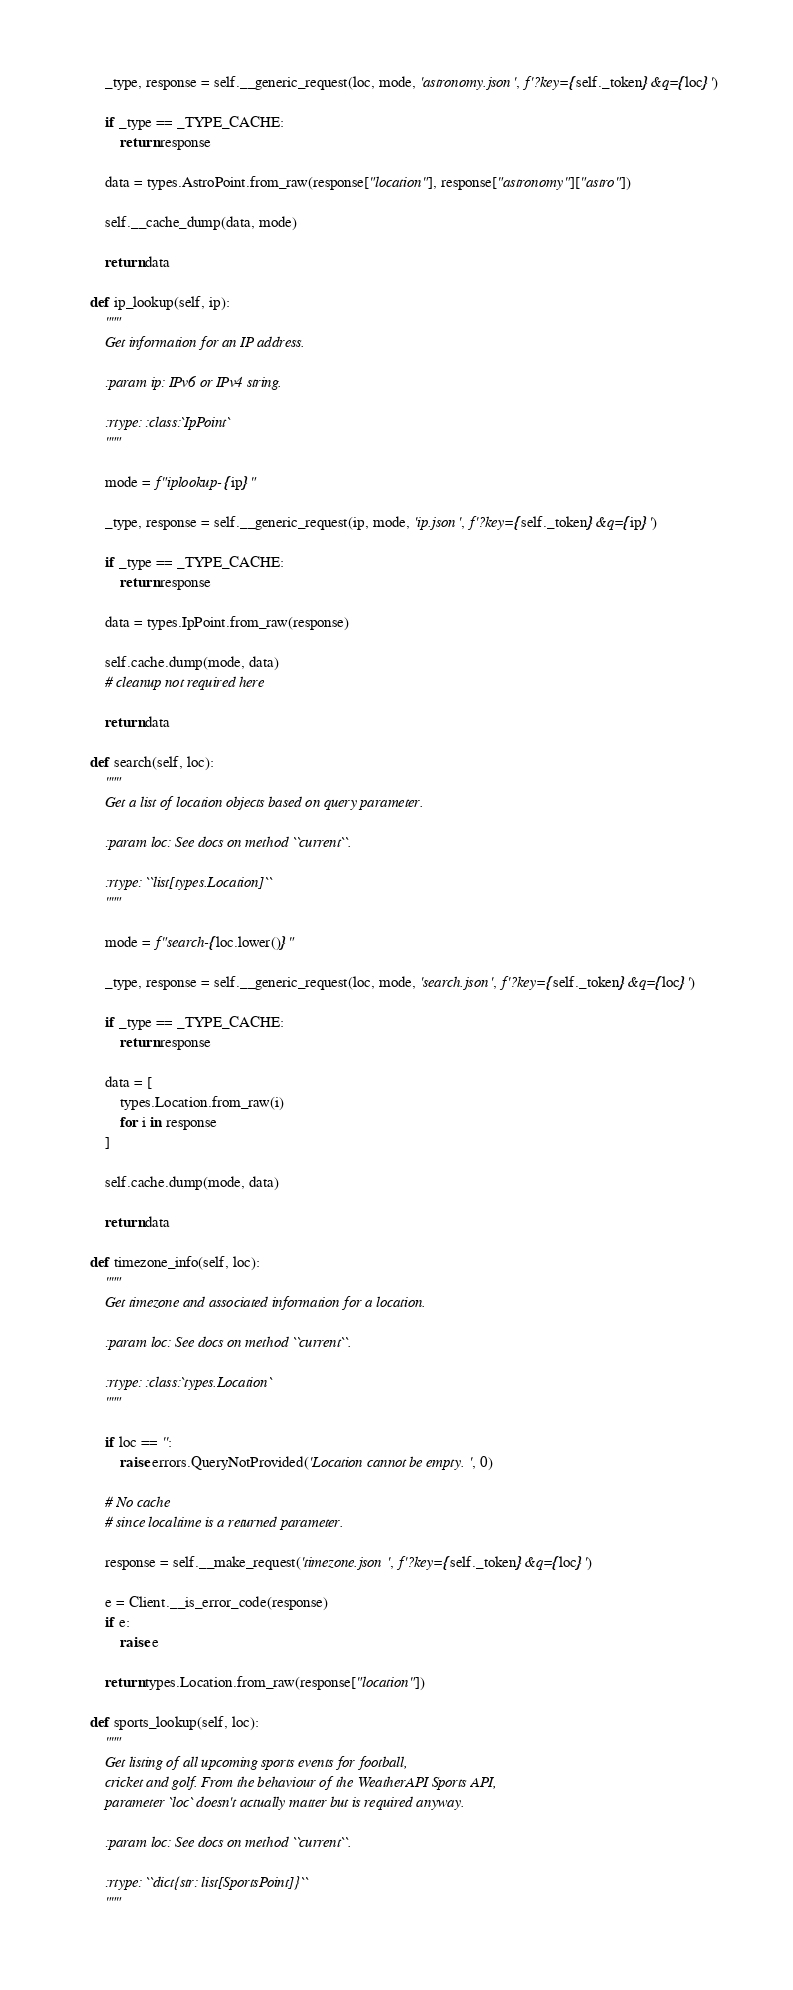<code> <loc_0><loc_0><loc_500><loc_500><_Python_>        _type, response = self.__generic_request(loc, mode, 'astronomy.json', f'?key={self._token}&q={loc}')

        if _type == _TYPE_CACHE:
            return response

        data = types.AstroPoint.from_raw(response["location"], response["astronomy"]["astro"])

        self.__cache_dump(data, mode)

        return data

    def ip_lookup(self, ip):
        """
        Get information for an IP address.

        :param ip: IPv6 or IPv4 string.

        :rtype: :class:`IpPoint`
        """

        mode = f"iplookup-{ip}"

        _type, response = self.__generic_request(ip, mode, 'ip.json', f'?key={self._token}&q={ip}')

        if _type == _TYPE_CACHE:
            return response

        data = types.IpPoint.from_raw(response)

        self.cache.dump(mode, data)
        # cleanup not required here

        return data

    def search(self, loc):
        """
        Get a list of location objects based on query parameter.

        :param loc: See docs on method ``current``.

        :rtype: ``list[types.Location]``
        """

        mode = f"search-{loc.lower()}"

        _type, response = self.__generic_request(loc, mode, 'search.json', f'?key={self._token}&q={loc}')

        if _type == _TYPE_CACHE:
            return response

        data = [
            types.Location.from_raw(i)
            for i in response
        ]

        self.cache.dump(mode, data)

        return data

    def timezone_info(self, loc):
        """
        Get timezone and associated information for a location.

        :param loc: See docs on method ``current``.

        :rtype: :class:`types.Location`
        """

        if loc == '':
            raise errors.QueryNotProvided('Location cannot be empty.', 0)

        # No cache
        # since localtime is a returned parameter.

        response = self.__make_request('timezone.json', f'?key={self._token}&q={loc}')

        e = Client.__is_error_code(response)
        if e:
            raise e

        return types.Location.from_raw(response["location"])

    def sports_lookup(self, loc):
        """
        Get listing of all upcoming sports events for football,
        cricket and golf. From the behaviour of the WeatherAPI Sports API,
        parameter `loc` doesn't actually matter but is required anyway.

        :param loc: See docs on method ``current``.

        :rtype: ``dict{str: list[SportsPoint]}``
        """</code> 